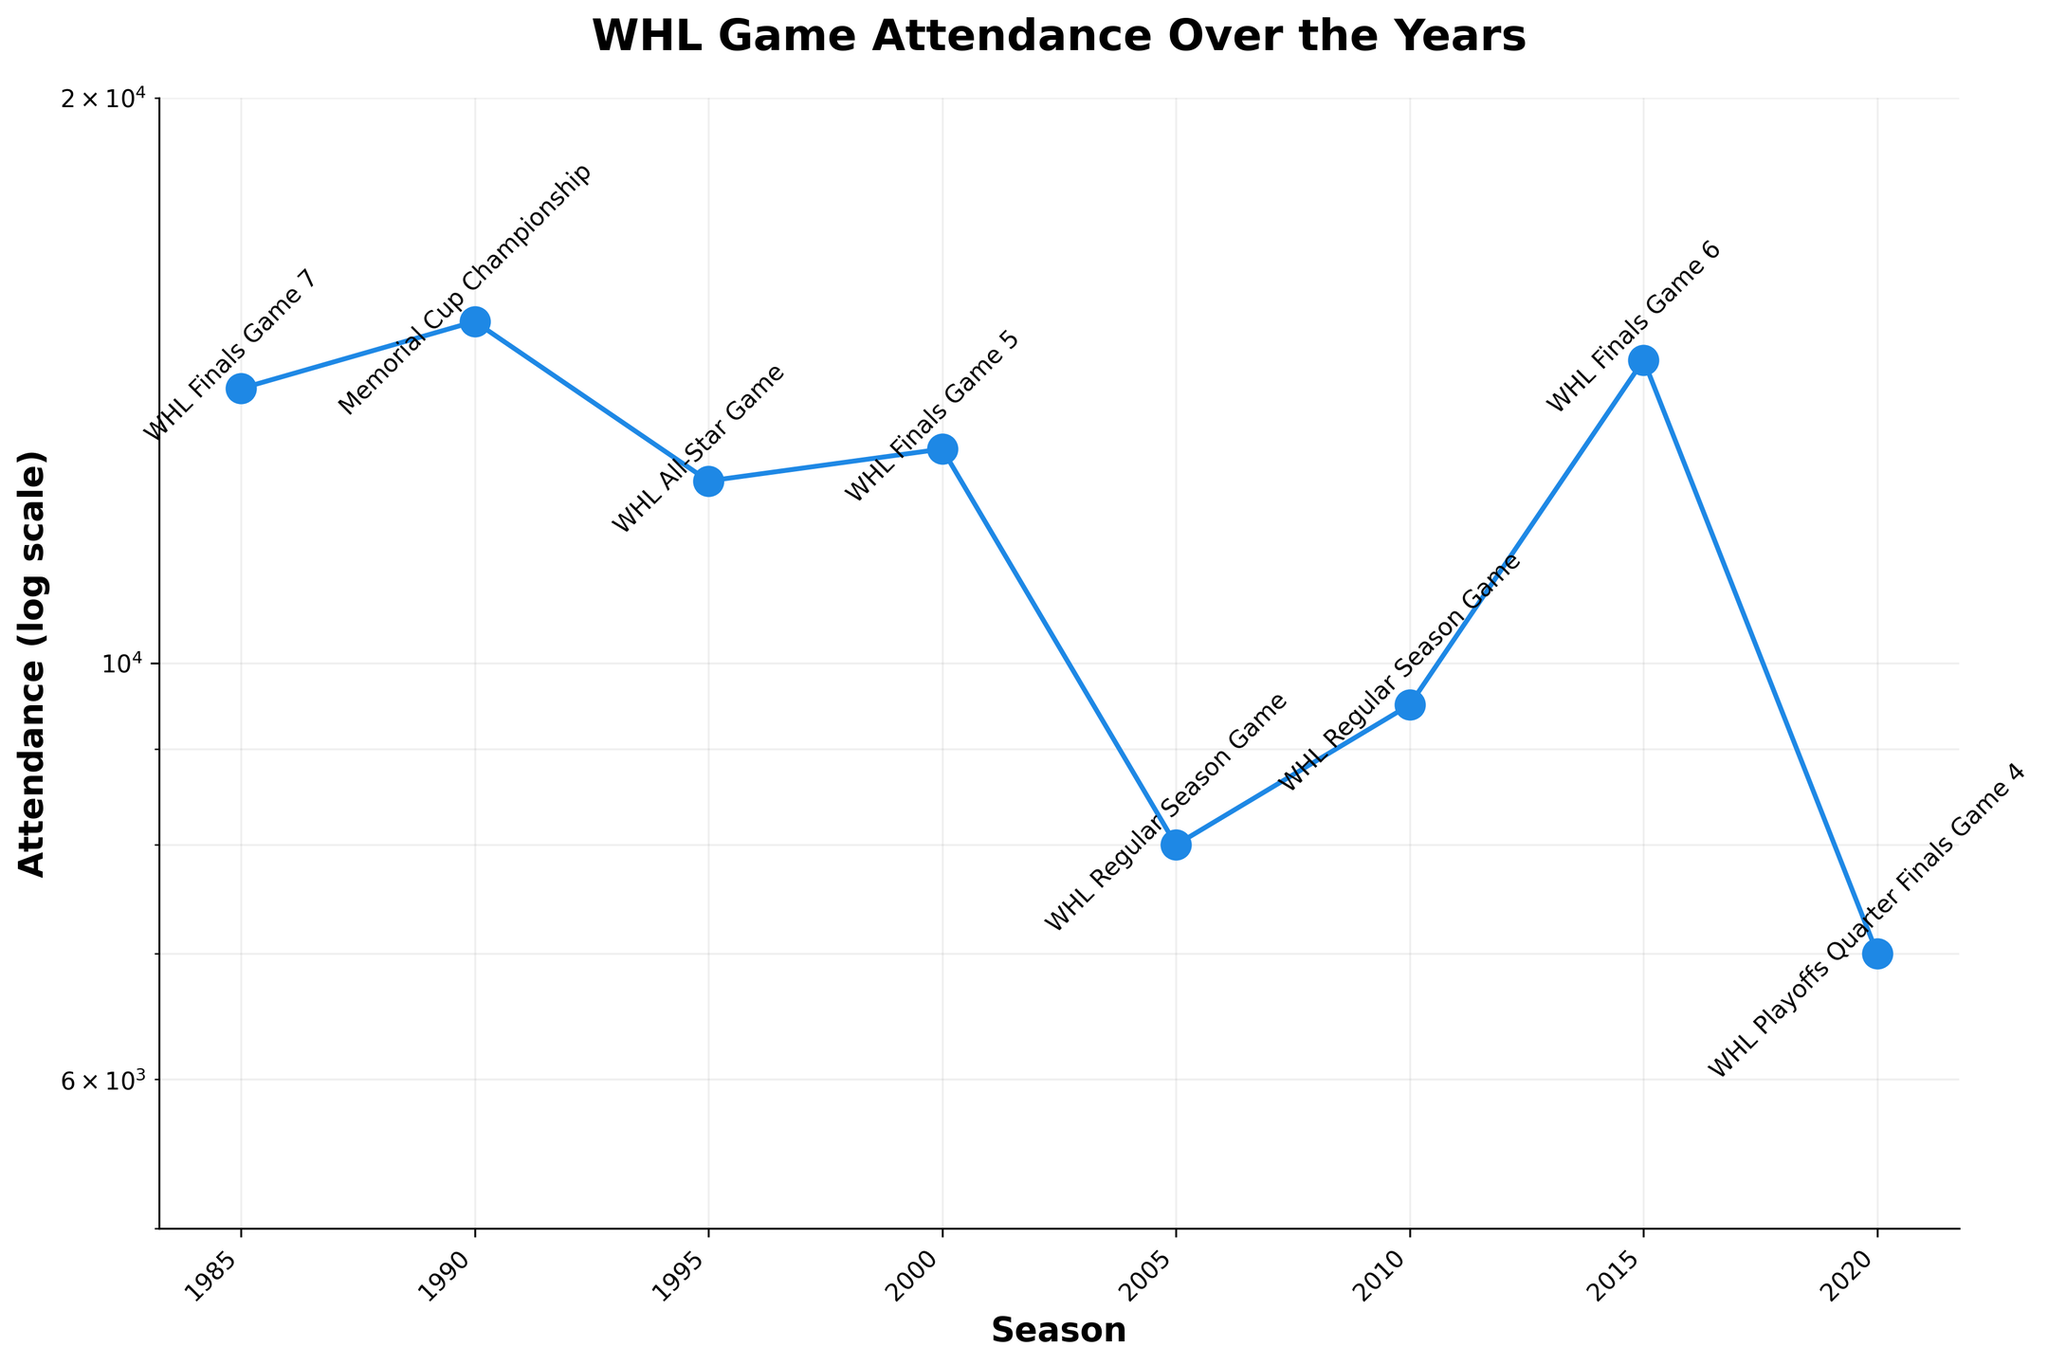What is the title of the plot? The title of the plot is displayed at the top and provides a summary of the visual information. By looking at the plot, you can see the title directly.
Answer: WHL Game Attendance Over the Years What is the attendance for the WHL Finals Game 7 in 1985? Find the data point labeled "1985" on the x-axis, and look at the corresponding y-value marked near the point with an annotation.
Answer: 14,000 How does the attendance for the WHL Regular Season Game in 2005 compare to that in 2010? Identify the data points for 2005 and 2010 on the x-axis, read their corresponding y-values, and compare them. The log scale might affect the visual distance.
Answer: The attendance in 2010 (9,500) is higher than in 2005 (8,000) Which season had the highest attendance, and what was the event? Identify the highest point on the y-axis (log scale) and look at its corresponding x-axis (season) to find the event annotated near it.
Answer: 1990, Memorial Cup Championship What is the range of attendances shown on the y-axis? Look at the y-axis labels to see the minimum and maximum values indicated by the tick marks.
Answer: 5,000 to 20,000 How much higher was the attendance for the WHL Finals Game 5 in 2000 compared to the WHL Playoffs Quarter Finals Game 4 in 2020? Locate the respective points on the plot, annotate their y-values, and then subtract the 2020 attendance from the 2000 attendance.
Answer: 6,000 higher What is the average attendance for the WHL events listed in the plot between 1985 and 2020? Sum the attendance values for all the points in the plot, then divide by the number of data points (8).
Answer: (14,000 + 15,200 + 12,500 + 13,000 + 8,000 + 9,500 + 14,500 + 7,000) / 8 = 11,575 How did the attendance trend for WHL Regular Season Games change from 2005 to 2010? Identify the points corresponding to 2005 and 2010 on the x-axis, check their y-values, and note the direction of the change.
Answer: Increased from 8,000 to 9,500 What is the most significant drop in attendance between any two consecutive events? Look at all consecutive pairs of data points, calculate the differences in their y-values, and identify the largest drop.
Answer: Between 2015 and 2020, dropping from 14,500 to 7,000 (7,500 drop) How does the attendance for the WHL All-Star Game in 1995 compare to the WHL Finals Game 6 in 2015? Locate the points for 1995 and 2015, read their y-values, and compare them.
Answer: The attendance in 2015 (14,500) is higher than in 1995 (12,500) 